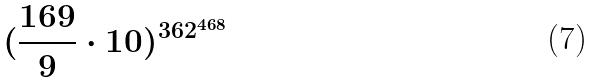<formula> <loc_0><loc_0><loc_500><loc_500>( \frac { 1 6 9 } { 9 } \cdot 1 0 ) ^ { 3 6 2 ^ { 4 6 8 } }</formula> 